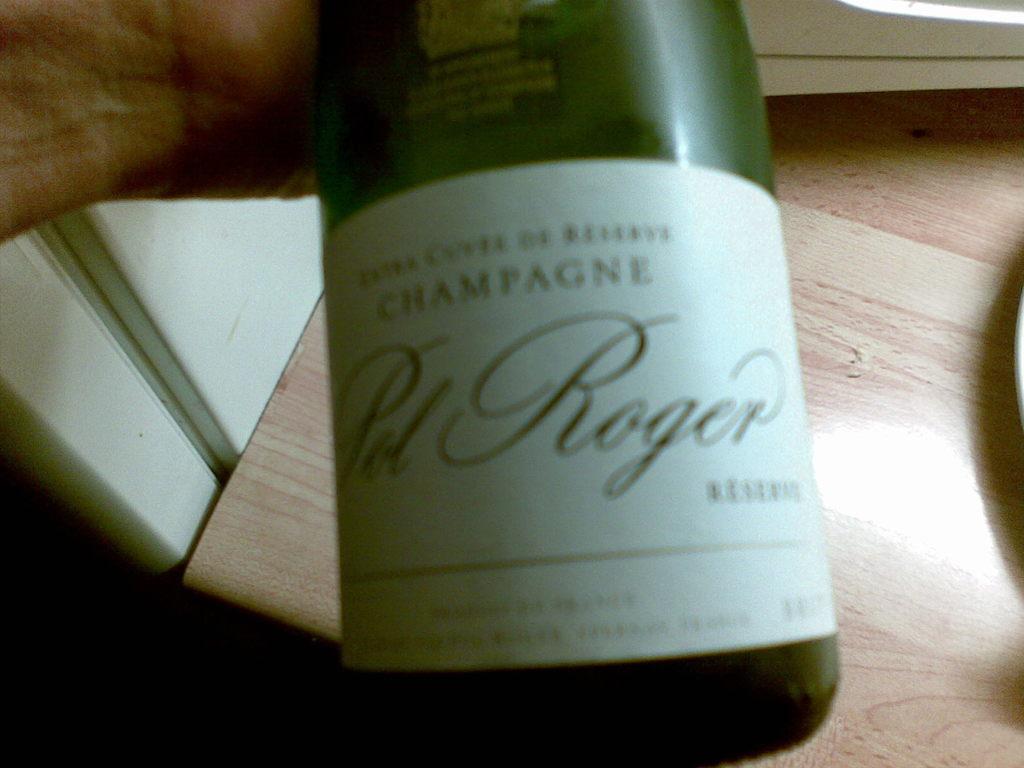What brand is the champagne?
Make the answer very short. Pol roger. What is in the bottle?
Your answer should be compact. Champagne. 